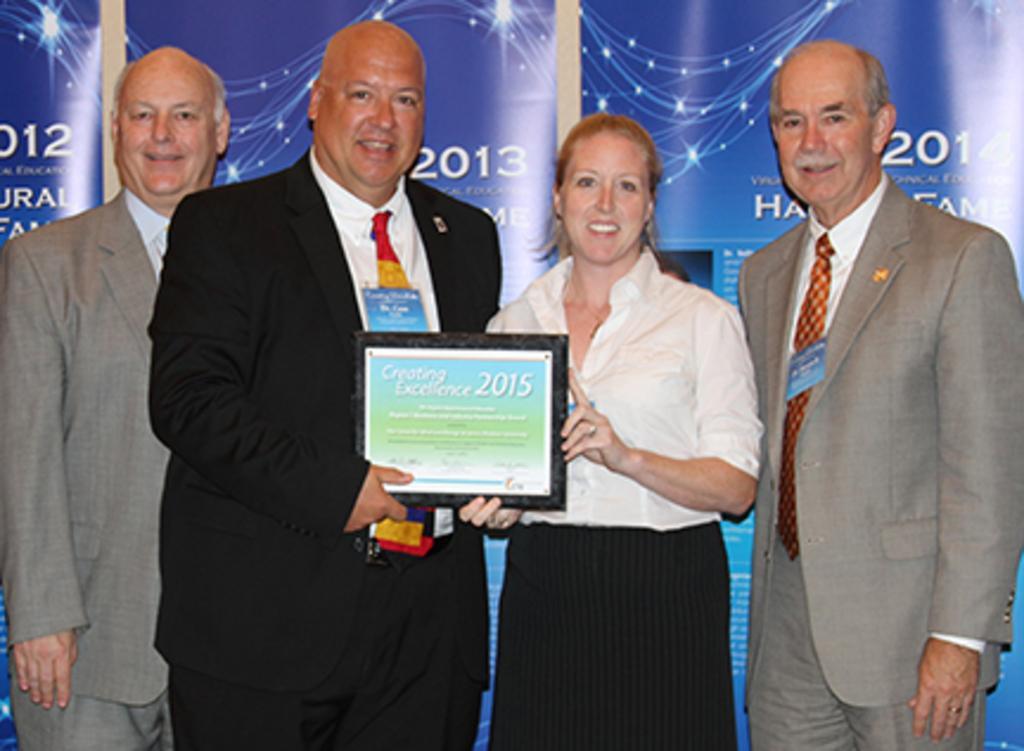Could you give a brief overview of what you see in this image? In the middle of the image four persons are standing, smiling and holding a frame. Behind them there is a banner. 